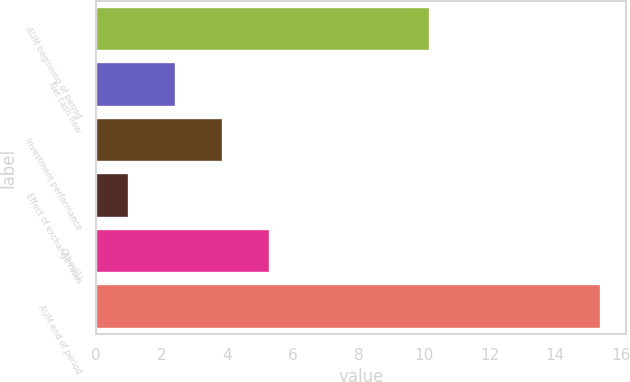Convert chart. <chart><loc_0><loc_0><loc_500><loc_500><bar_chart><fcel>AUM beginning of period<fcel>Net cash flow<fcel>Investment performance<fcel>Effect of exchange rates<fcel>Other(1)<fcel>AUM end of period<nl><fcel>10.2<fcel>2.44<fcel>3.88<fcel>1<fcel>5.32<fcel>15.4<nl></chart> 